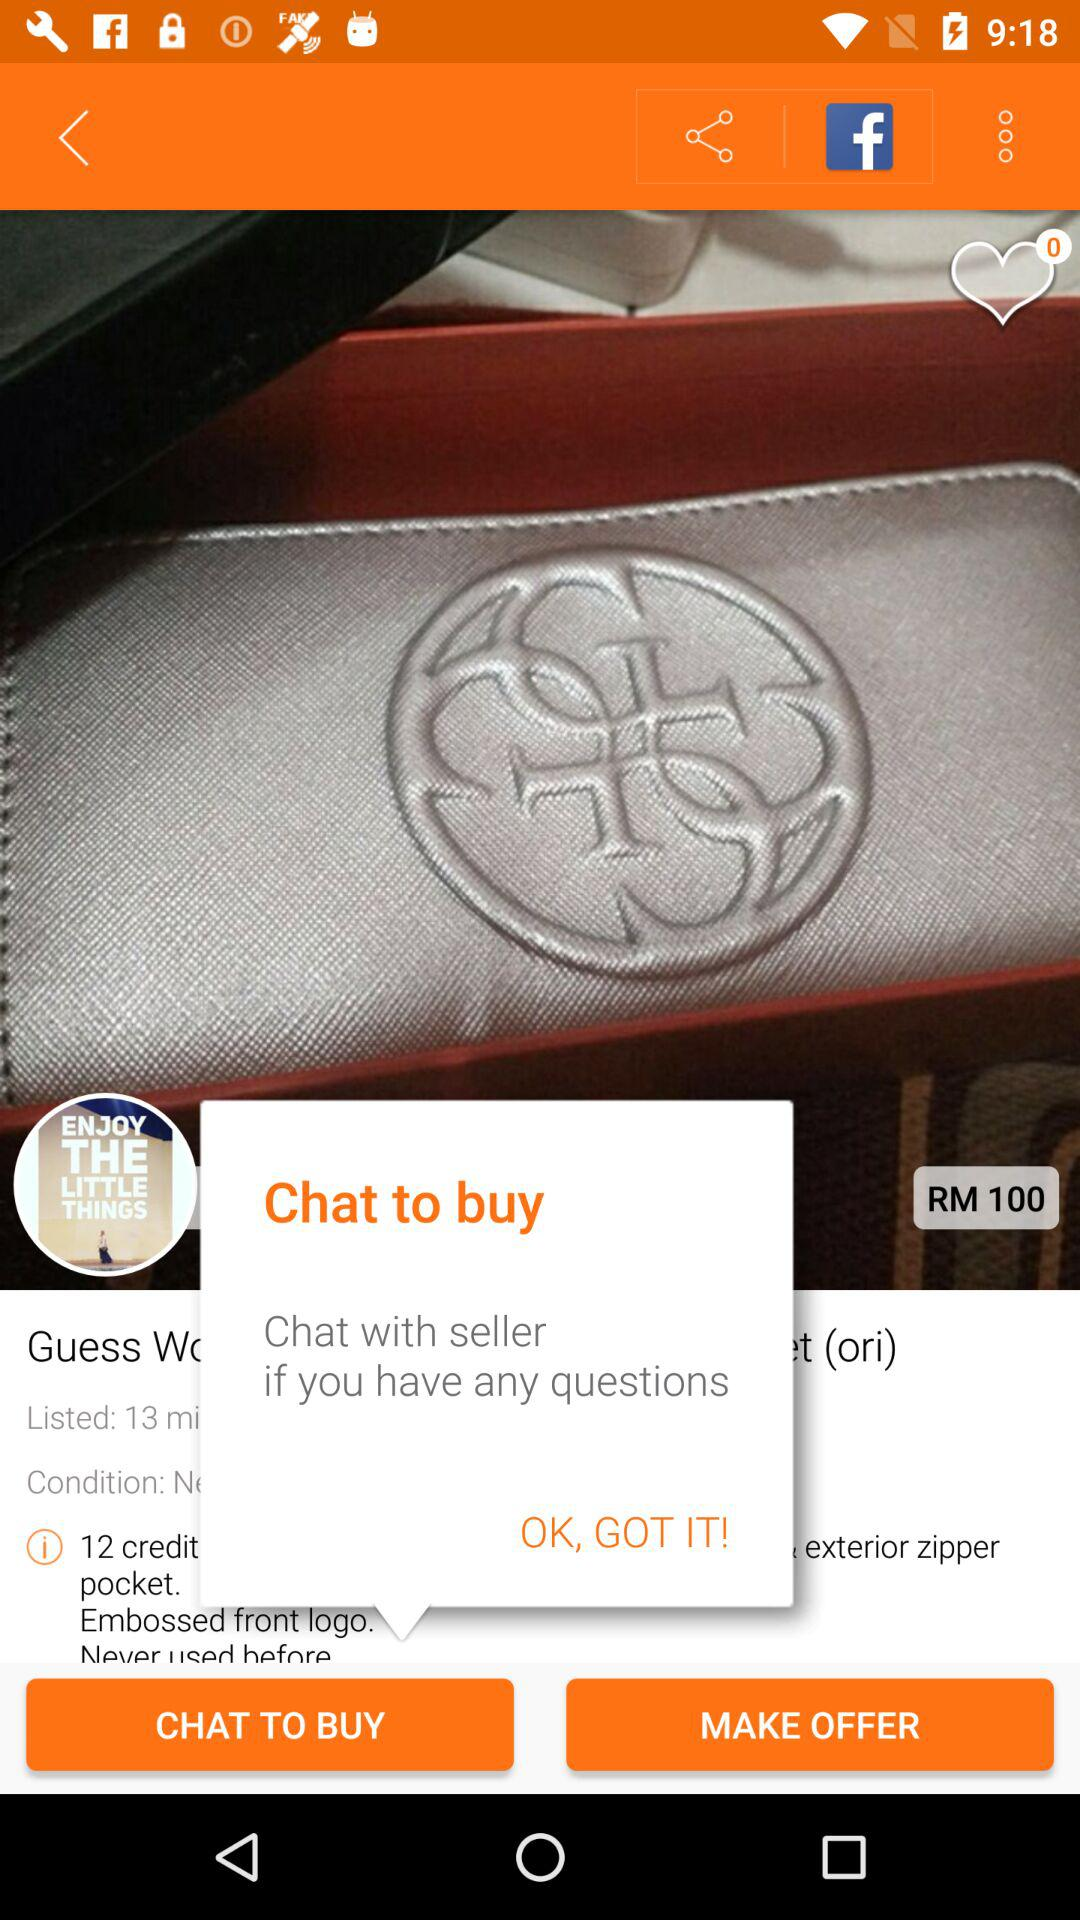Can you describe the logo embossed on the wallet? Certainly! The wallet features an embossed logo which seems to comprise intertwined letters, adding a touch of sophisticated branding to the design. What could be the material of the wallet? The wallet appears to have a sleek, possibly synthetic finish which suggests material like faux leather, commonly used for durability and a stylish aesthetic. 